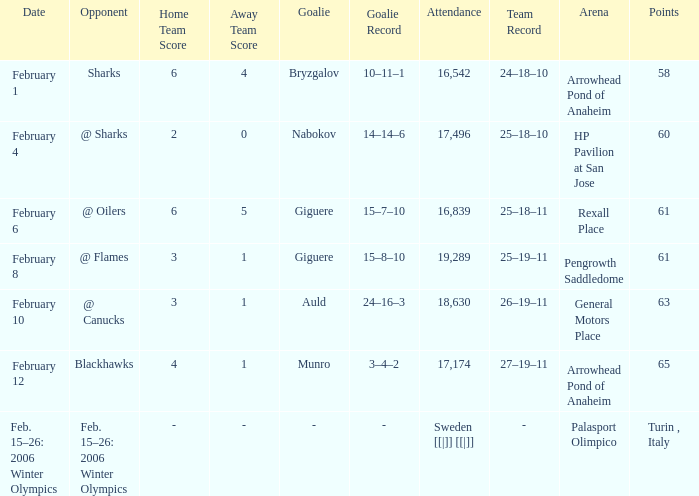What were the points on February 10? 63.0. 